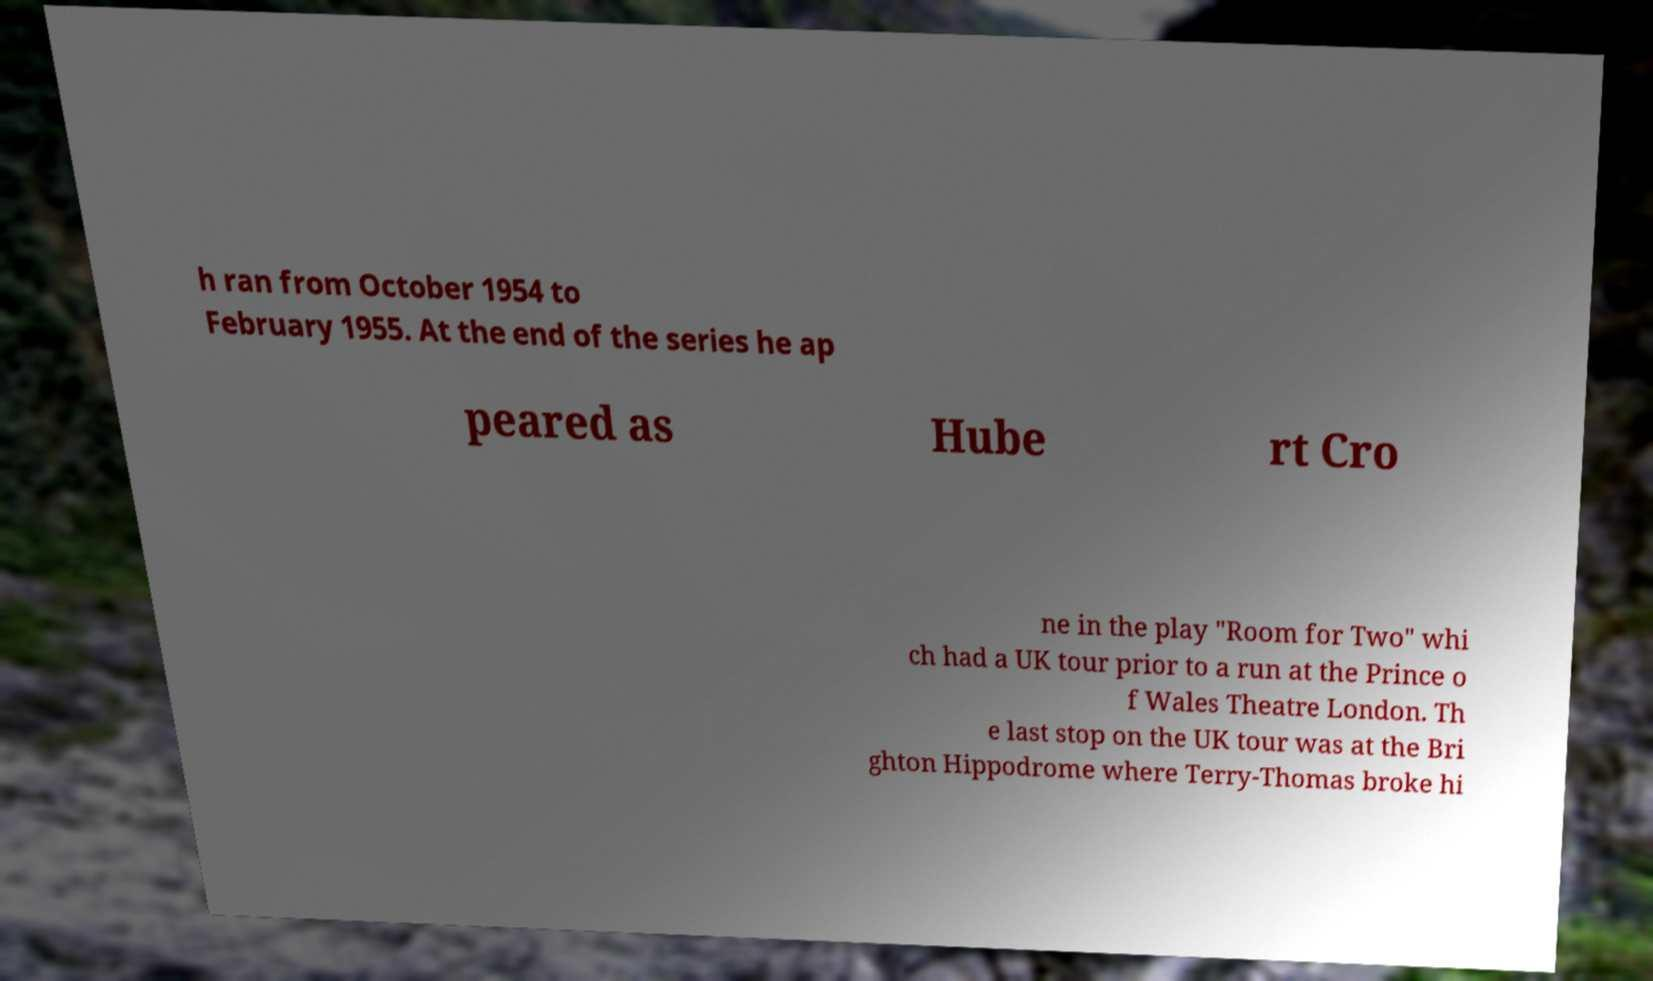Could you extract and type out the text from this image? h ran from October 1954 to February 1955. At the end of the series he ap peared as Hube rt Cro ne in the play "Room for Two" whi ch had a UK tour prior to a run at the Prince o f Wales Theatre London. Th e last stop on the UK tour was at the Bri ghton Hippodrome where Terry-Thomas broke hi 